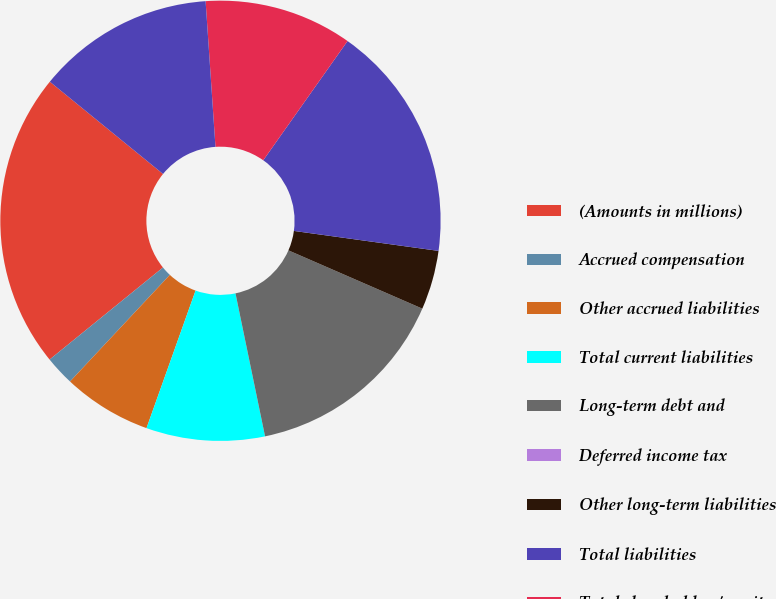Convert chart to OTSL. <chart><loc_0><loc_0><loc_500><loc_500><pie_chart><fcel>(Amounts in millions)<fcel>Accrued compensation<fcel>Other accrued liabilities<fcel>Total current liabilities<fcel>Long-term debt and<fcel>Deferred income tax<fcel>Other long-term liabilities<fcel>Total liabilities<fcel>Total shareholders' equity<fcel>Total equity<nl><fcel>21.74%<fcel>2.17%<fcel>6.52%<fcel>8.7%<fcel>15.22%<fcel>0.0%<fcel>4.35%<fcel>17.39%<fcel>10.87%<fcel>13.04%<nl></chart> 